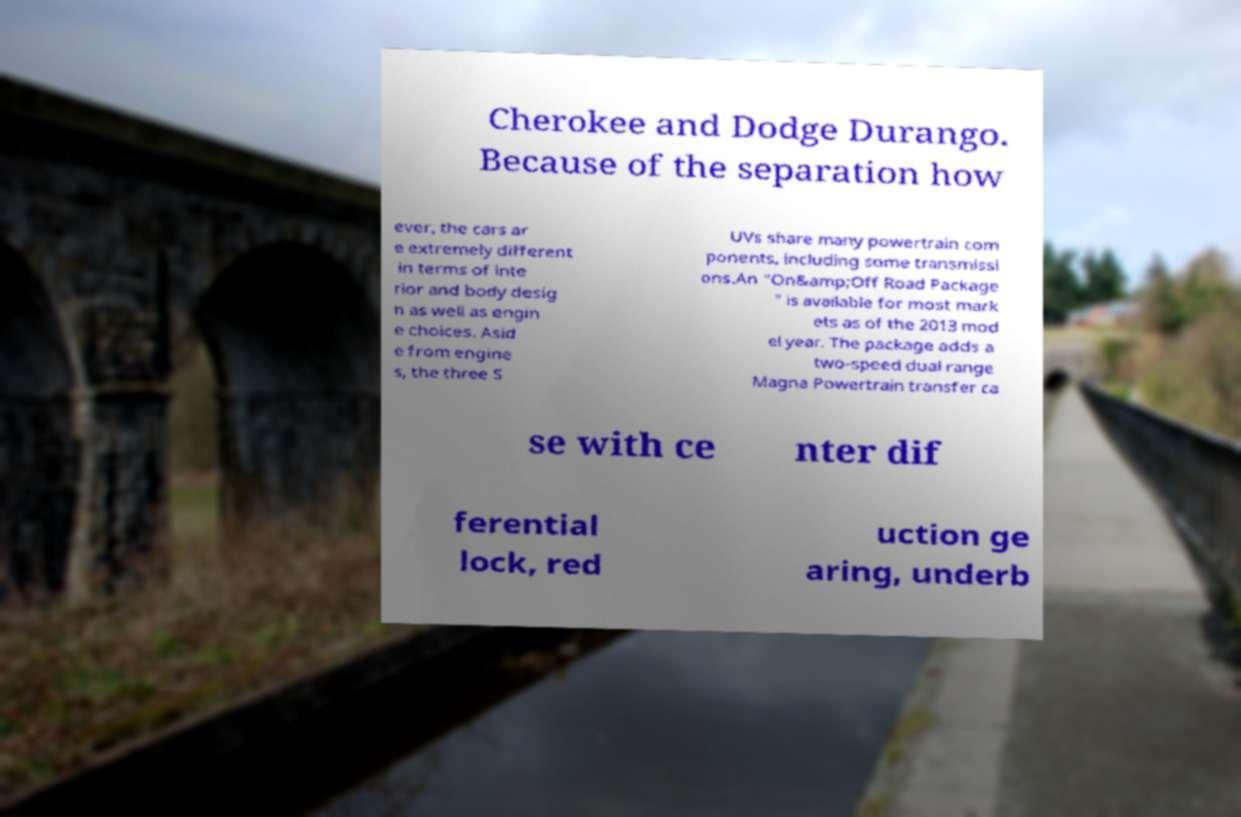Could you extract and type out the text from this image? Cherokee and Dodge Durango. Because of the separation how ever, the cars ar e extremely different in terms of inte rior and body desig n as well as engin e choices. Asid e from engine s, the three S UVs share many powertrain com ponents, including some transmissi ons.An "On&amp;Off Road Package " is available for most mark ets as of the 2013 mod el year. The package adds a two-speed dual range Magna Powertrain transfer ca se with ce nter dif ferential lock, red uction ge aring, underb 